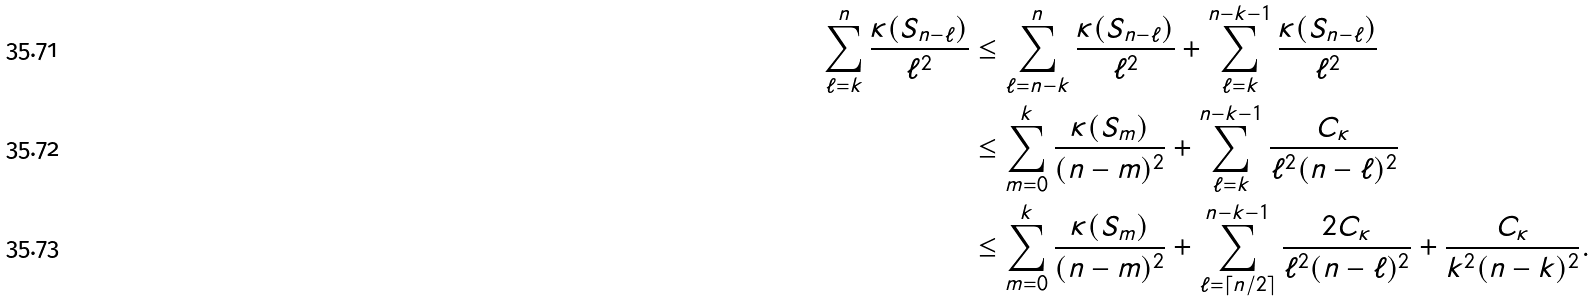<formula> <loc_0><loc_0><loc_500><loc_500>\sum _ { \ell = k } ^ { n } \frac { \kappa ( S _ { n - \ell } ) } { \ell ^ { 2 } } & \leq \sum _ { \ell = n - k } ^ { n } \frac { \kappa ( S _ { n - \ell } ) } { \ell ^ { 2 } } + \sum _ { \ell = k } ^ { n - k - 1 } \frac { \kappa ( S _ { n - \ell } ) } { \ell ^ { 2 } } \\ & \leq \sum _ { m = 0 } ^ { k } \frac { \kappa ( S _ { m } ) } { ( n - m ) ^ { 2 } } + \sum _ { \ell = k } ^ { n - k - 1 } \frac { C _ { \kappa } } { \ell ^ { 2 } ( n - \ell ) ^ { 2 } } \\ & \leq \sum _ { m = 0 } ^ { k } \frac { \kappa ( S _ { m } ) } { ( n - m ) ^ { 2 } } + \sum _ { \ell = \lceil n / 2 \rceil } ^ { n - k - 1 } \frac { 2 C _ { \kappa } } { \ell ^ { 2 } ( n - \ell ) ^ { 2 } } + \frac { C _ { \kappa } } { k ^ { 2 } ( n - k ) ^ { 2 } } .</formula> 